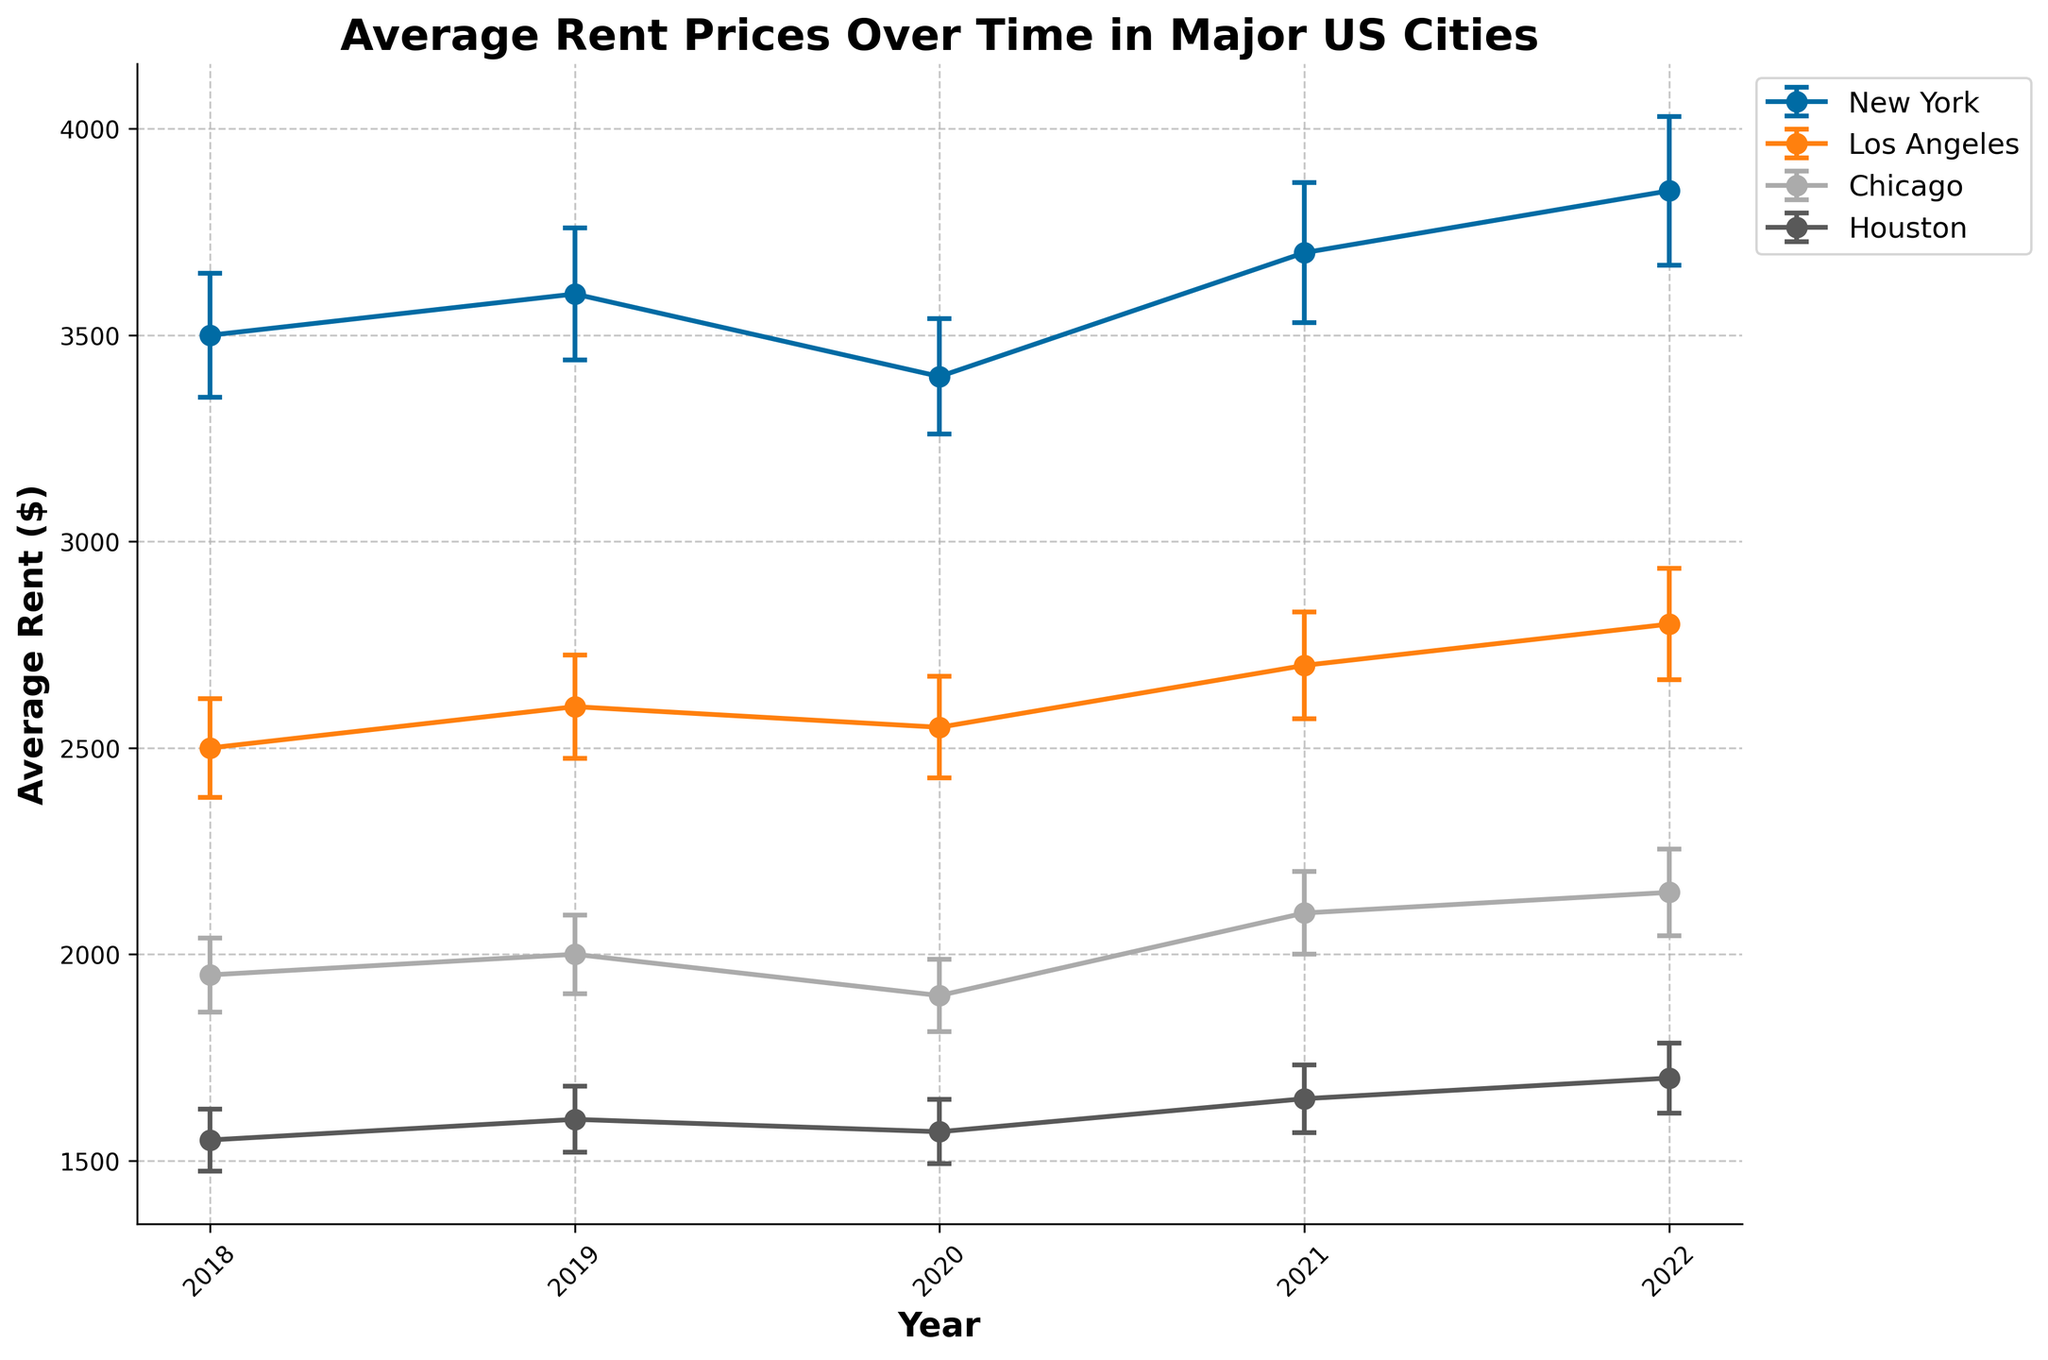What is the title of the figure? The title of the figure is often displayed prominently at the top and provides a summary of what the figure represents. In this case, the title describes the data presented in the figure.
Answer: Average Rent Prices Over Time in Major US Cities Which city had the highest average rent in 2022? To find out which city had the highest average rent in 2022, look at the points for each city on the year 2022 on the x-axis and compare their heights. New York's point is the highest.
Answer: New York What is the average rent in Chicago in 2020 and its standard deviation? Identify the data points for Chicago in 2020 by looking along the x-axis and finding the corresponding y-axis value for Chicago. The error bar indicates the standard deviation.
Answer: $1900, $88 How did the rent in Los Angeles change from 2018 to 2022? To find the change in rent for Los Angeles from 2018 to 2022, look at the y-axis values for Los Angeles in 2018 and 2022 and calculate the difference.
Answer: Increased by $300 Which city had the most significant increase in average rent from 2020 to 2021? Compare the difference in average rents between the points for 2021 and 2020 for each city and find the largest increase.
Answer: New York Was there any decrease in rent for any city from one year to the next? If so, which city and years? Examine the line segments year by year for each city to identify any decrease. New York from 2019 to 2020 and Chicago from 2019 to 2020 both have decreases.
Answer: New York (2019-2020), Chicago (2019-2020) What was the average rent in Houston in 2019 and 2020, and what was the change? Find Houston's data points for 2019 and 2020 on the y-axis and calculate the difference between them.
Answer: $1600 in 2019, $1570 in 2020, decreased by $30 Which city had the smallest variation in average rent prices over the years? Compare the lengths of the error bars for each city across the years. The city with the shortest error bars on average has the smallest variation.
Answer: Houston How did average rent prices change from 2018 to 2022 in New York and Chicago? Find the data points for New York and Chicago in 2018 and 2022 and note the rent values, then compute the difference for both cities.
Answer: New York increased by $350, Chicago increased by $200 What is the trend in average rent prices for Los Angeles from 2018 to 2022? Observe the direction of the line plot for Los Angeles from 2018 to 2022. The overall trend will indicate whether the rent prices are increasing or decreasing.
Answer: Increasing 